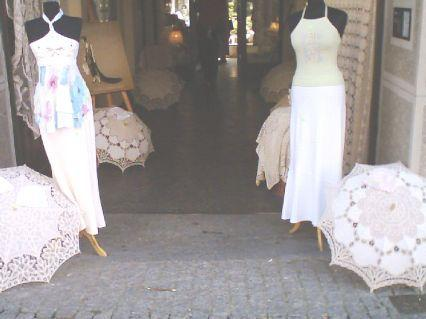How many dresses are sat around the entryway to the hall?

Choices:
A) four
B) three
C) five
D) two two 